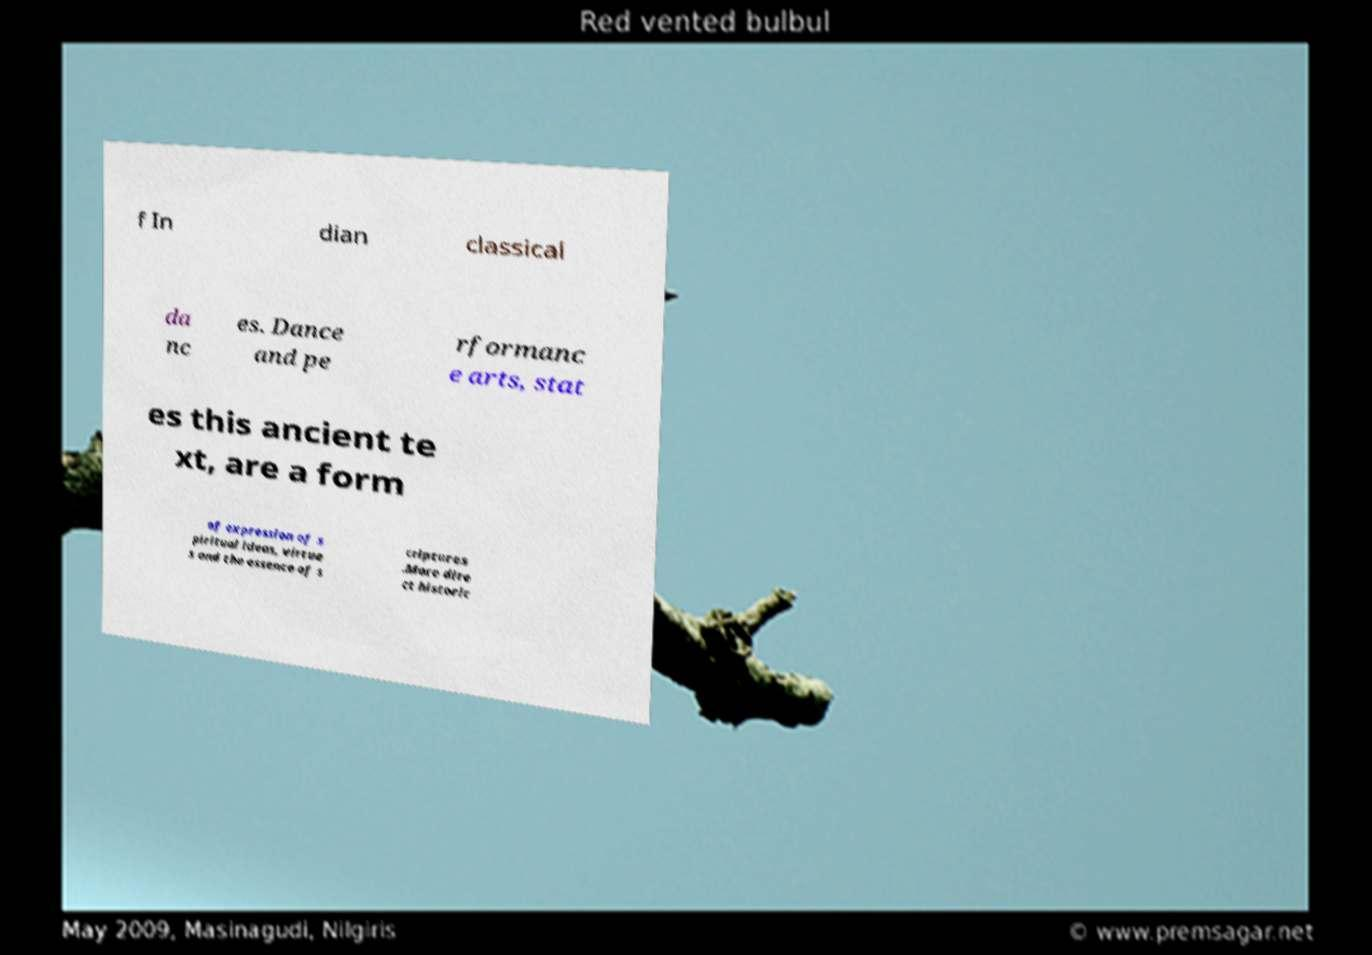Can you read and provide the text displayed in the image?This photo seems to have some interesting text. Can you extract and type it out for me? f In dian classical da nc es. Dance and pe rformanc e arts, stat es this ancient te xt, are a form of expression of s piritual ideas, virtue s and the essence of s criptures .More dire ct historic 